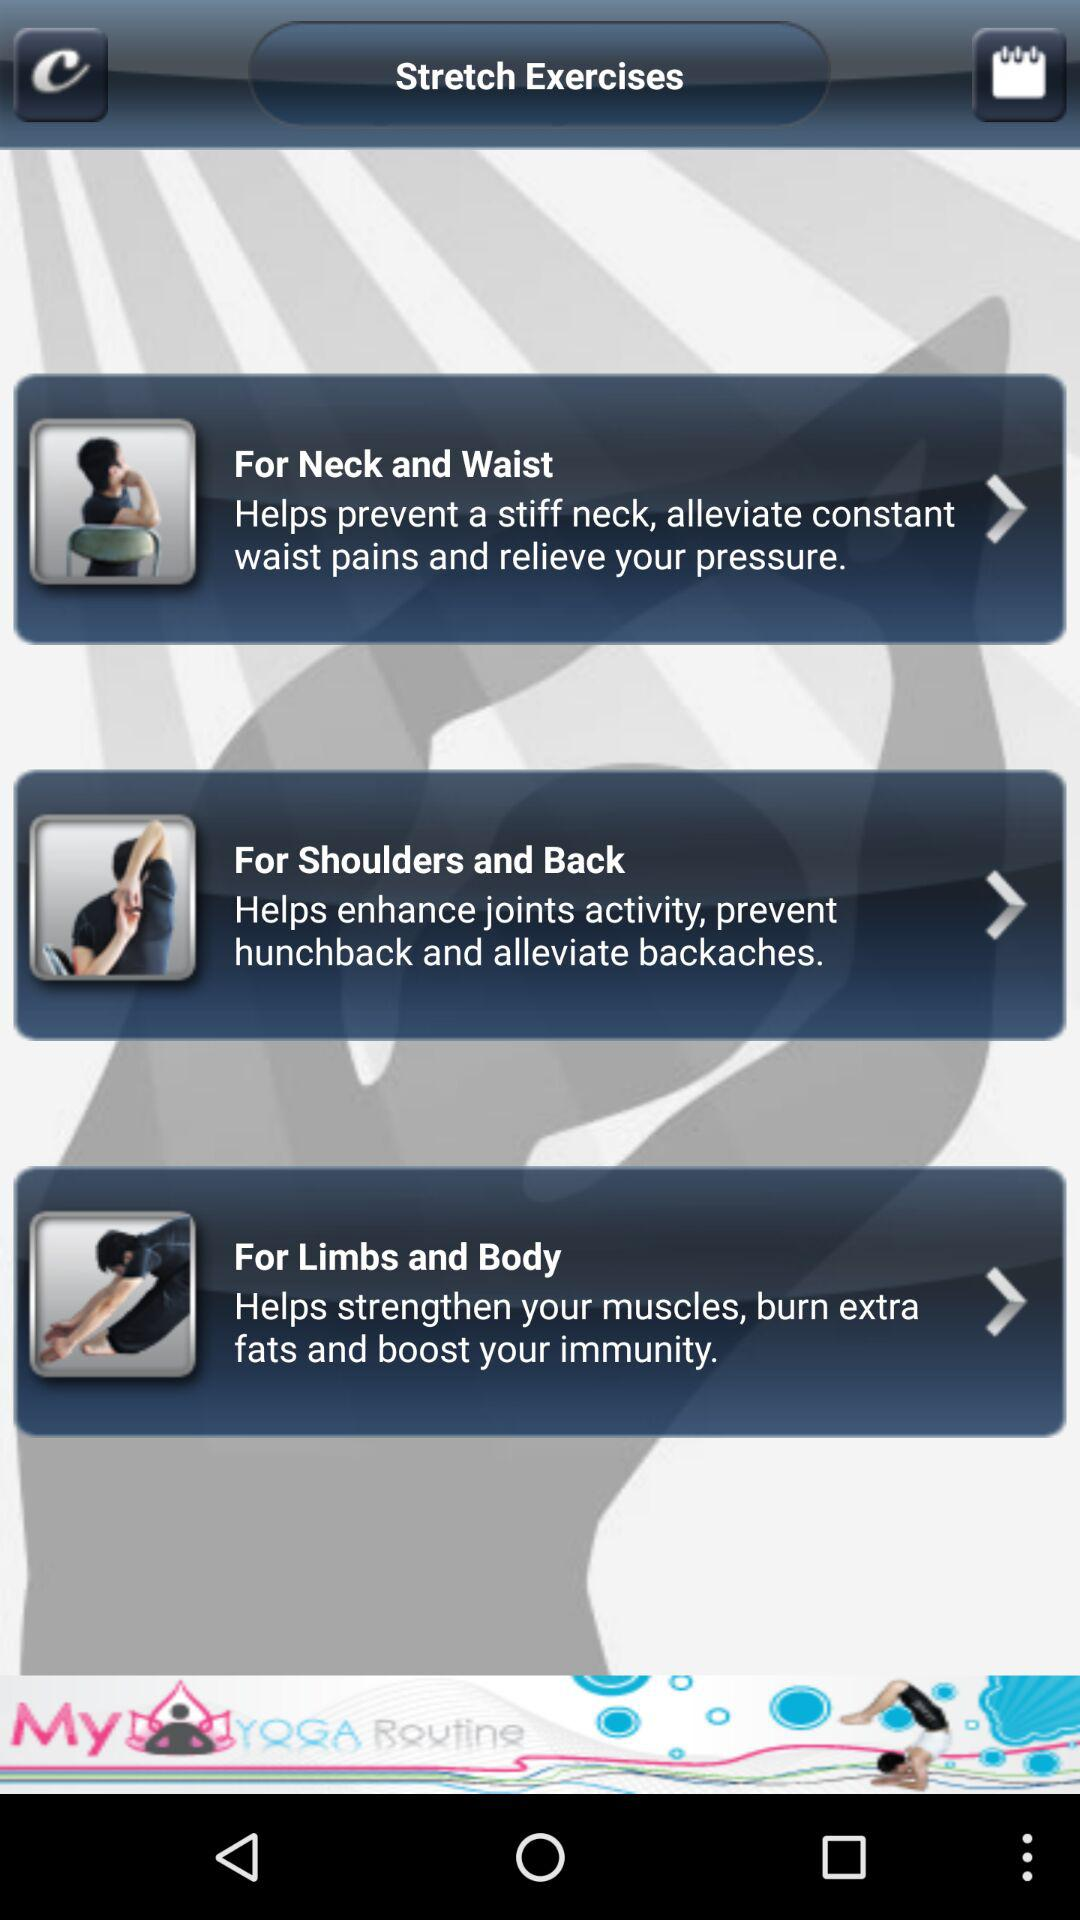How many exercises are there in total?
Answer the question using a single word or phrase. 3 